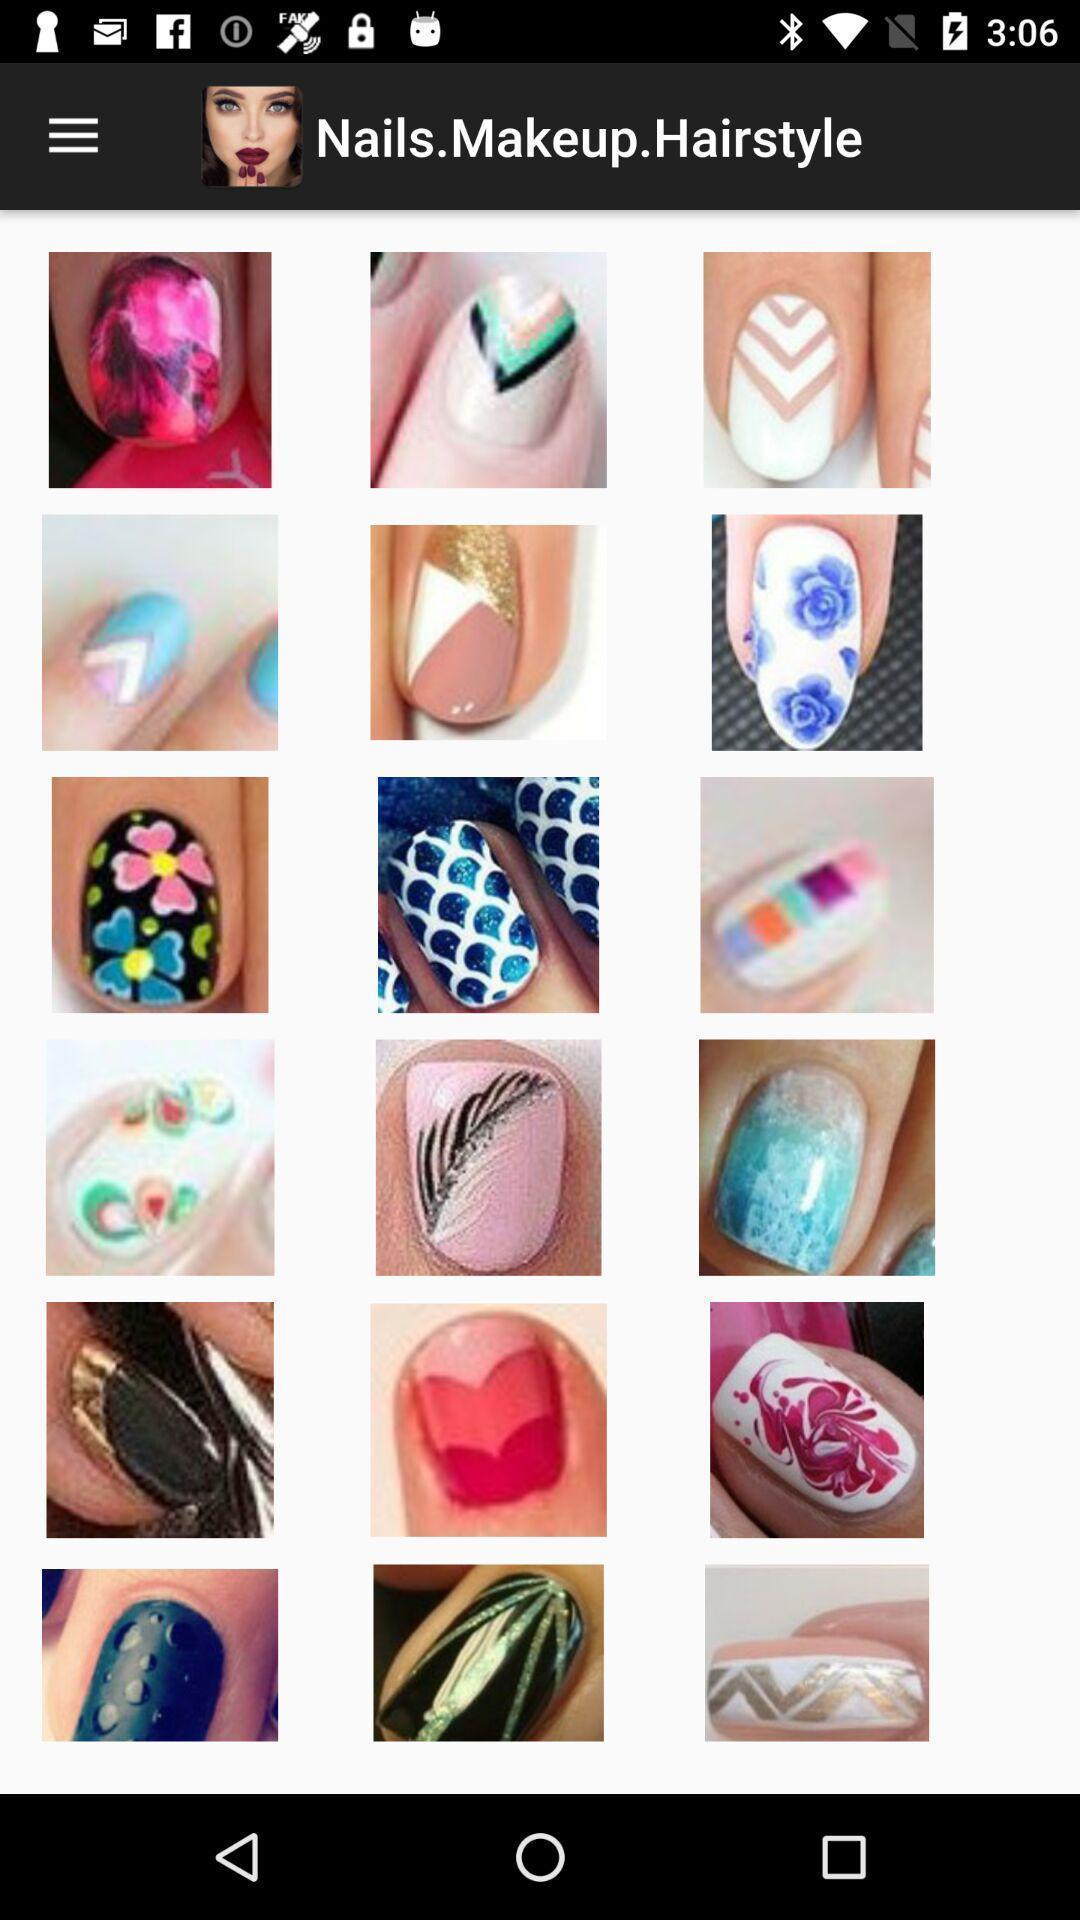What is the overall content of this screenshot? Various types of nail polishs in the application. 